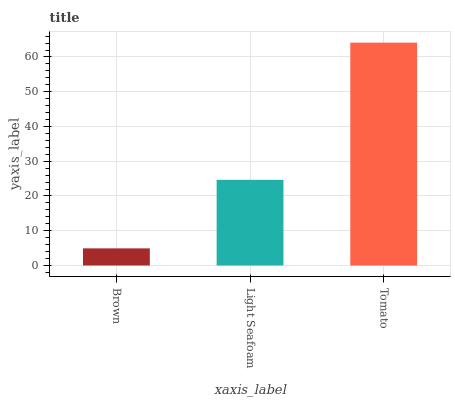Is Brown the minimum?
Answer yes or no. Yes. Is Tomato the maximum?
Answer yes or no. Yes. Is Light Seafoam the minimum?
Answer yes or no. No. Is Light Seafoam the maximum?
Answer yes or no. No. Is Light Seafoam greater than Brown?
Answer yes or no. Yes. Is Brown less than Light Seafoam?
Answer yes or no. Yes. Is Brown greater than Light Seafoam?
Answer yes or no. No. Is Light Seafoam less than Brown?
Answer yes or no. No. Is Light Seafoam the high median?
Answer yes or no. Yes. Is Light Seafoam the low median?
Answer yes or no. Yes. Is Brown the high median?
Answer yes or no. No. Is Brown the low median?
Answer yes or no. No. 